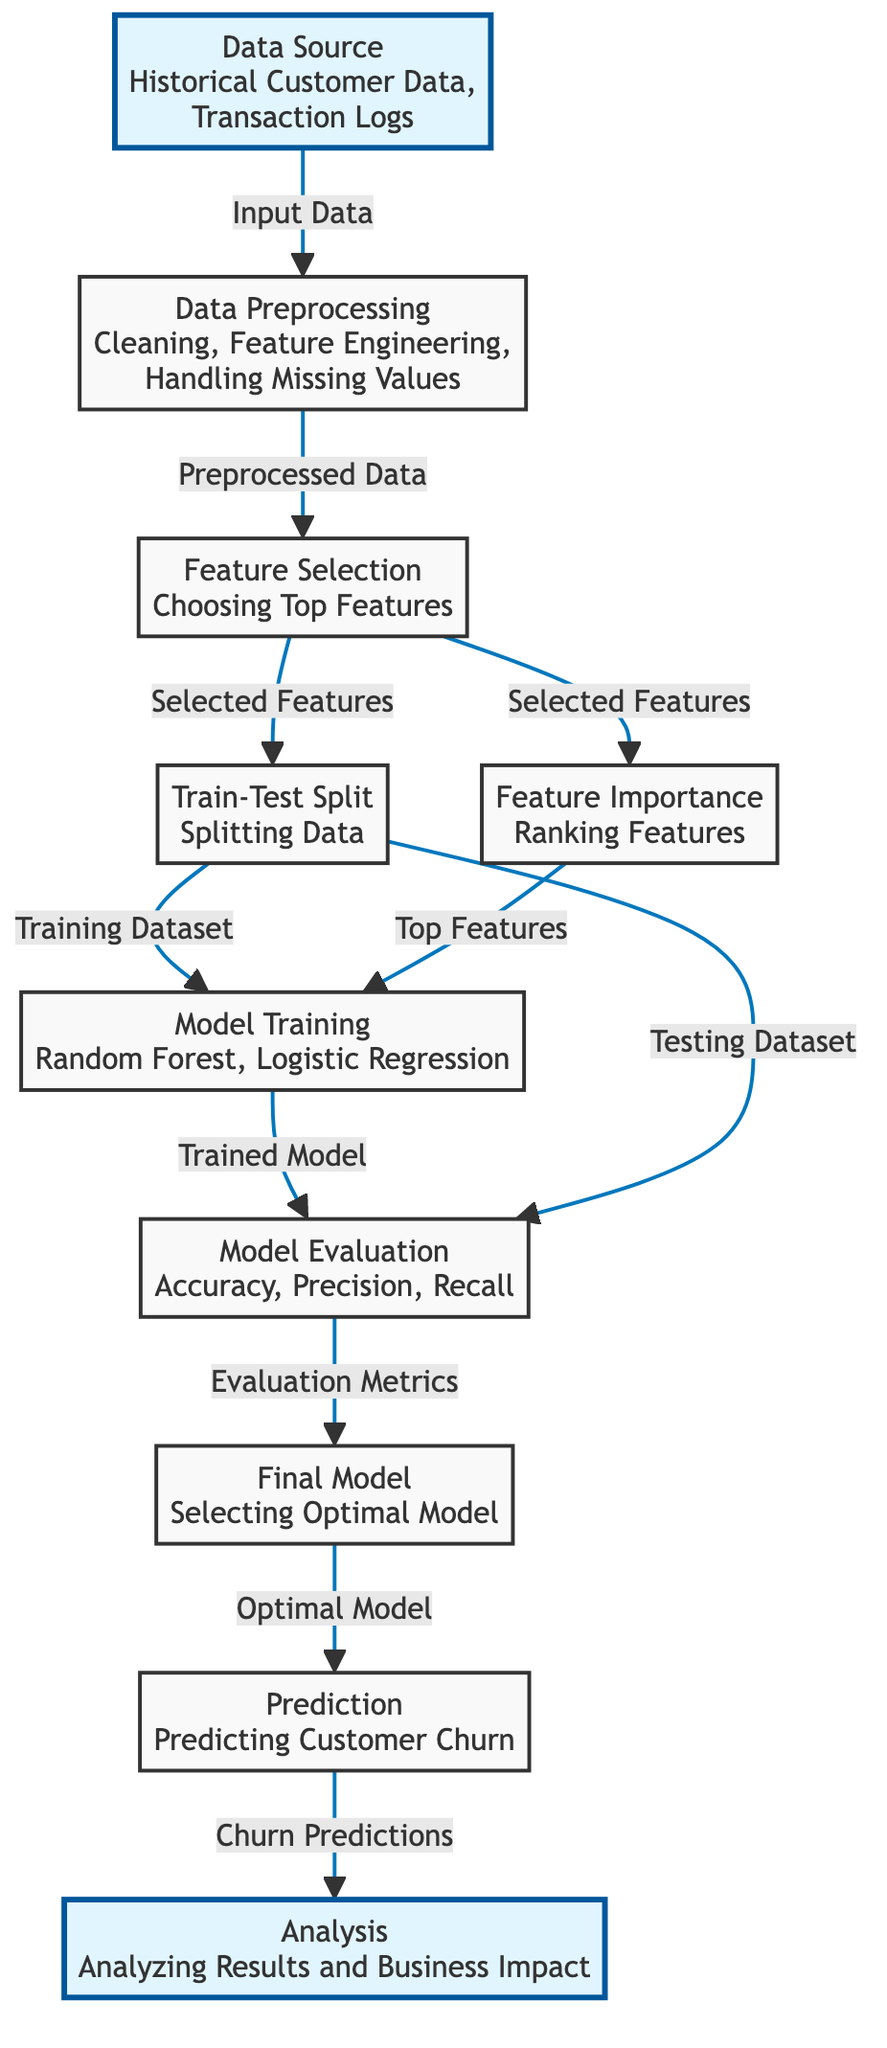What is the main input to the diagram? The diagram begins with "Data Source" which contains "Historical Customer Data" and "Transaction Logs" as its main input
Answer: Historical Customer Data, Transaction Logs How many main processes are involved in the diagram? The diagram outlines 9 main processes, starting from Data Source to Analysis
Answer: 9 What follows data preprocessing in the diagram? After data preprocessing, the next step is Feature Selection, which involves choosing the top features
Answer: Feature Selection What type of models are used for training according to the diagram? The diagram specifies "Random Forest" and "Logistic Regression" as the models used for training
Answer: Random Forest, Logistic Regression Which process is connected to the "Model Evaluation"? The node connected to "Model Evaluation" is "Model Training", indicating that evaluation follows the training process
Answer: Model Training What is the outcome of the "Prediction" process in the diagram? The outcome of the "Prediction" process is "Churn Predictions", indicating that customer churn is forecasted
Answer: Churn Predictions What step occurs after "Feature Importance"? After determining feature importance, the next step is "Model Training", where the features are used to train the model
Answer: Model Training Which two nodes connect to "Model Evaluation"? "Train-Test Split" provides the "Training Dataset" and the "Testing Dataset" both lead to "Model Evaluation"
Answer: Train-Test Split What is the focus of the final step in the diagram? The final step indicated in the diagram is "Analysis", which focuses on analyzing the results and assessing the business impact
Answer: Analysis 